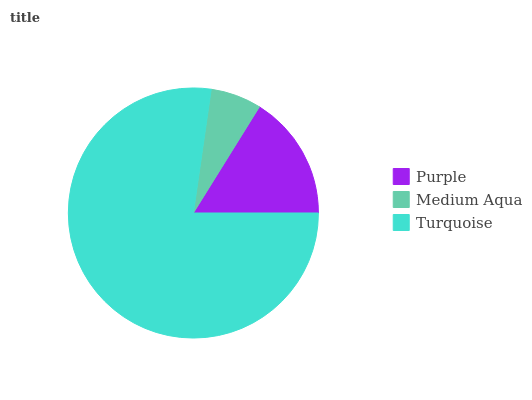Is Medium Aqua the minimum?
Answer yes or no. Yes. Is Turquoise the maximum?
Answer yes or no. Yes. Is Turquoise the minimum?
Answer yes or no. No. Is Medium Aqua the maximum?
Answer yes or no. No. Is Turquoise greater than Medium Aqua?
Answer yes or no. Yes. Is Medium Aqua less than Turquoise?
Answer yes or no. Yes. Is Medium Aqua greater than Turquoise?
Answer yes or no. No. Is Turquoise less than Medium Aqua?
Answer yes or no. No. Is Purple the high median?
Answer yes or no. Yes. Is Purple the low median?
Answer yes or no. Yes. Is Turquoise the high median?
Answer yes or no. No. Is Turquoise the low median?
Answer yes or no. No. 